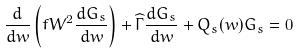Convert formula to latex. <formula><loc_0><loc_0><loc_500><loc_500>\frac { d } { d w } \left ( f W ^ { 2 } \frac { d G _ { s } } { d w } \right ) + \widehat { \Gamma } \frac { d G _ { s } } { d w } + Q _ { s } ( w ) G _ { s } = 0</formula> 